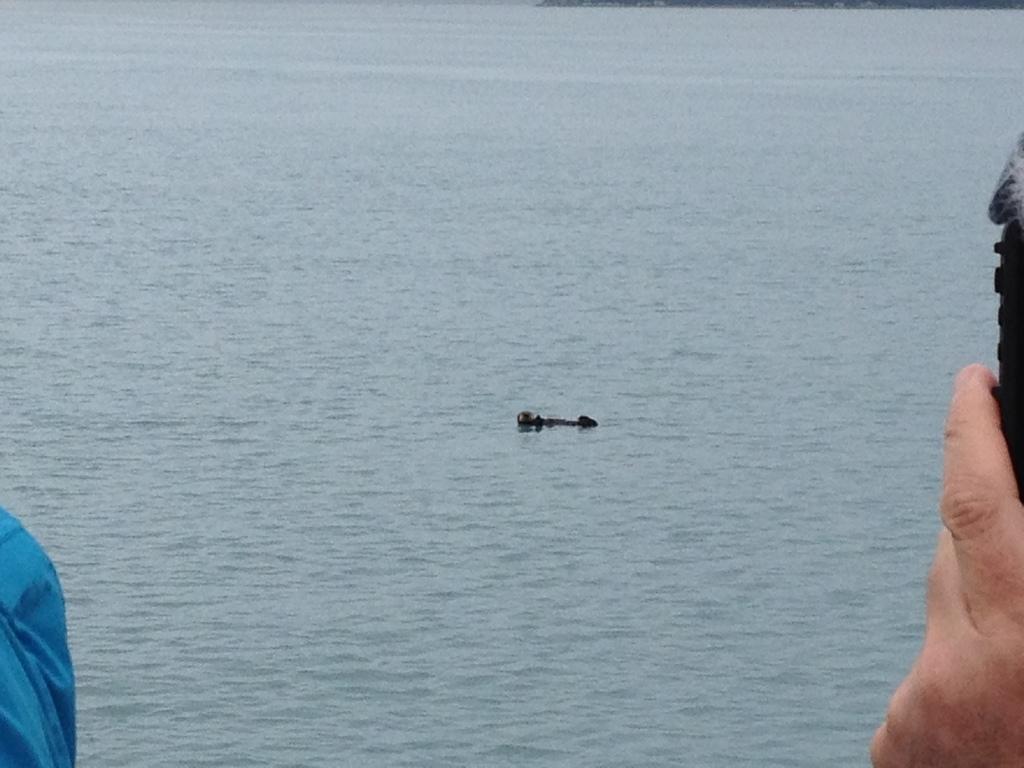In one or two sentences, can you explain what this image depicts? In this image we can see the hand of a person holding an object. On the backside we can see an object floating on the water. 